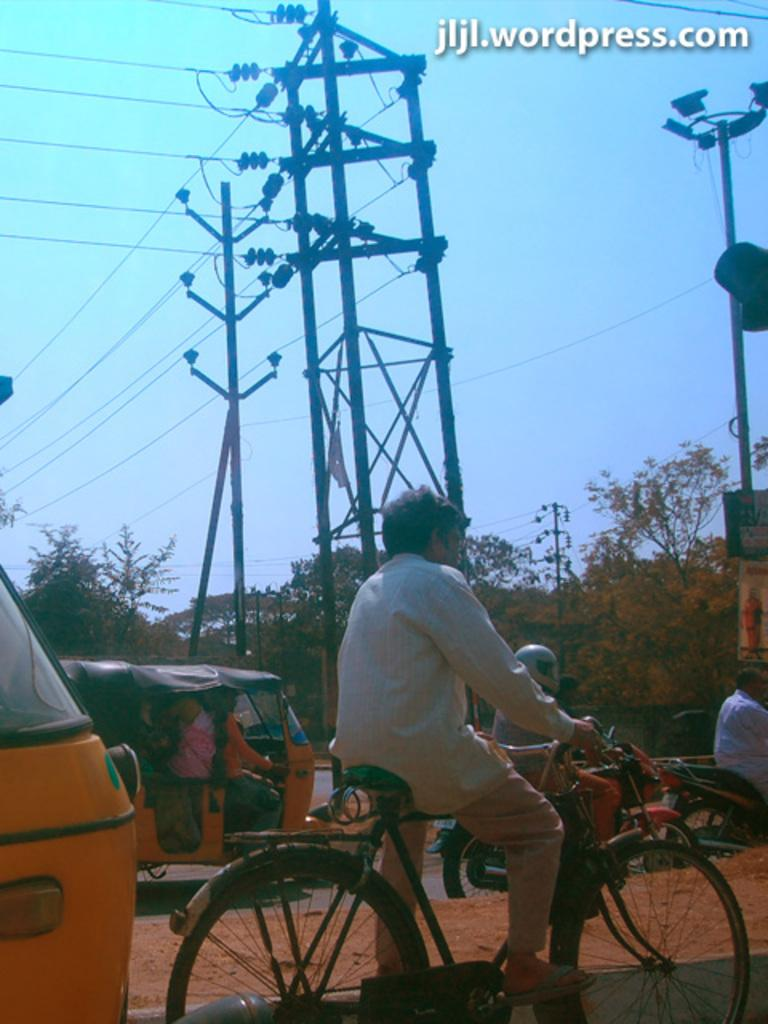What is on the road in the image? There is a vehicle on the road in the image. What mode of transportation is the man using? The man is riding a bicycle. What is attached to the current pole in the image? There are cables attached to the current pole in the image. What can be seen in the distance in the image? Trees are visible in the distance. What type of drink is being used as bait for the fish in the image? There is no drink or fish present in the image; it features a vehicle on the road, a man riding a bicycle, a current pole with cables, and trees in the distance. 